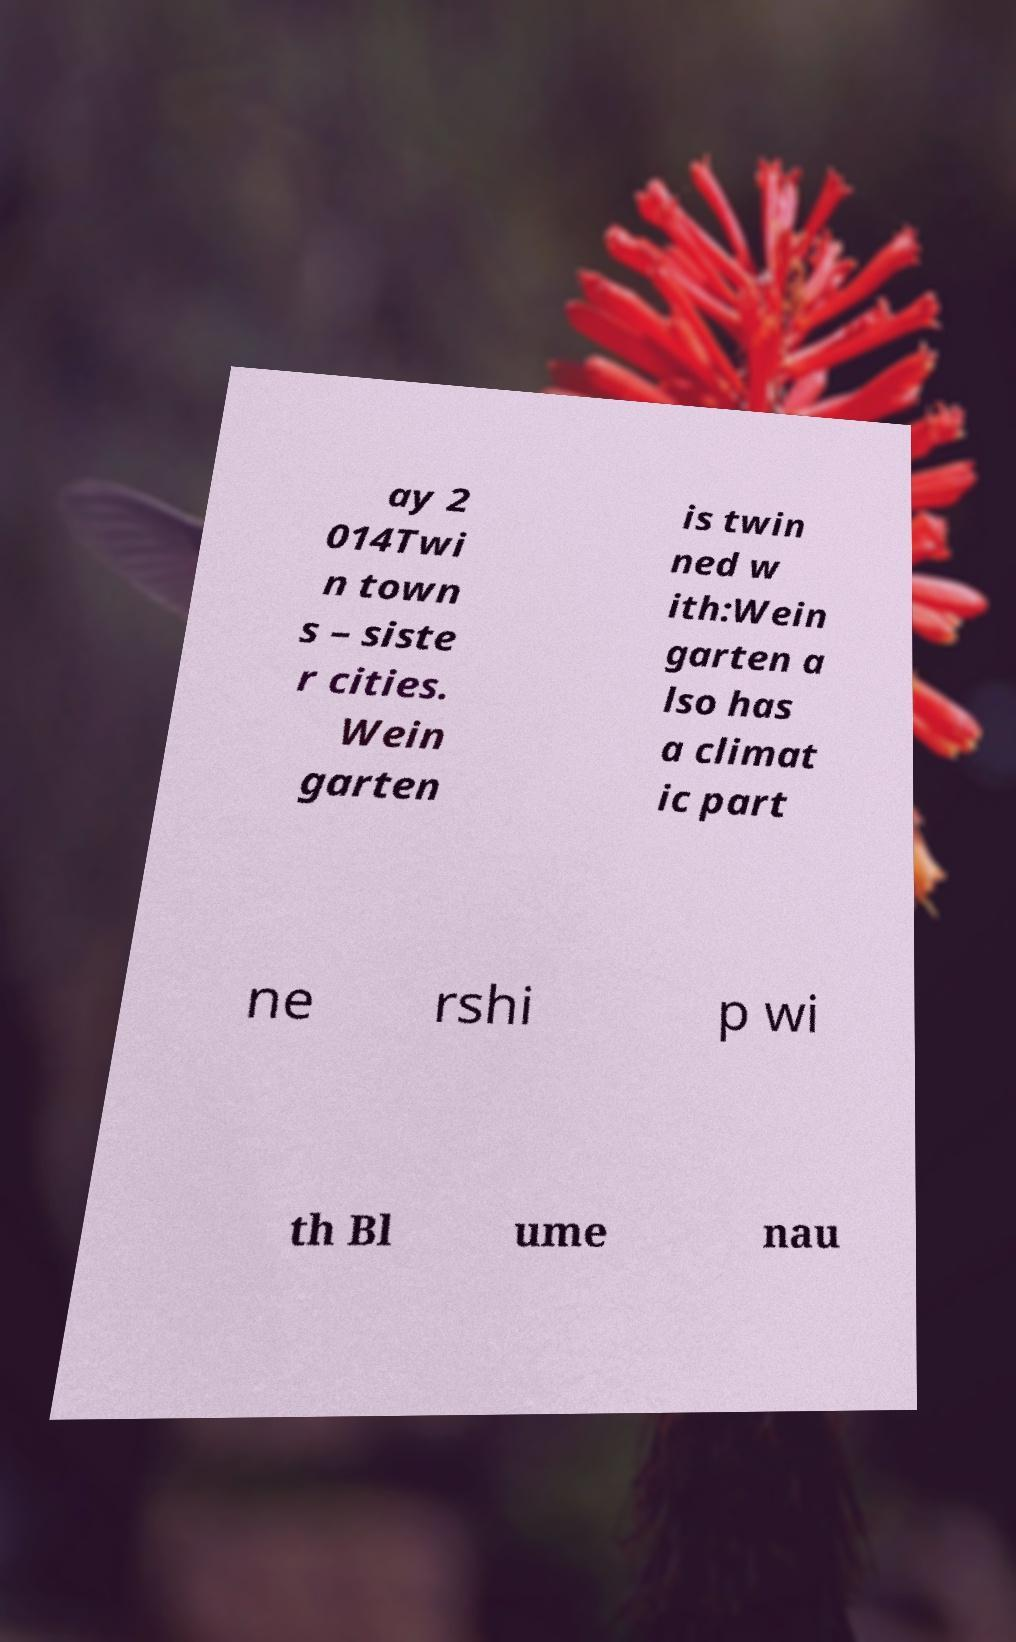What messages or text are displayed in this image? I need them in a readable, typed format. ay 2 014Twi n town s – siste r cities. Wein garten is twin ned w ith:Wein garten a lso has a climat ic part ne rshi p wi th Bl ume nau 